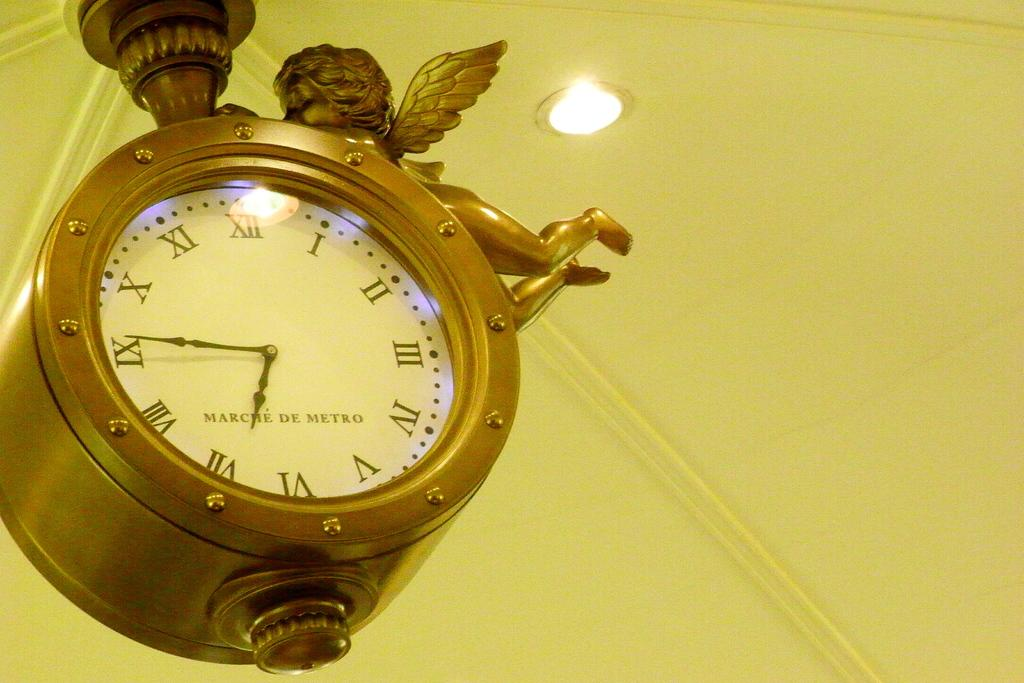<image>
Write a terse but informative summary of the picture. A cherub is holding onto a brass clock that shows the time is about 6:45. 